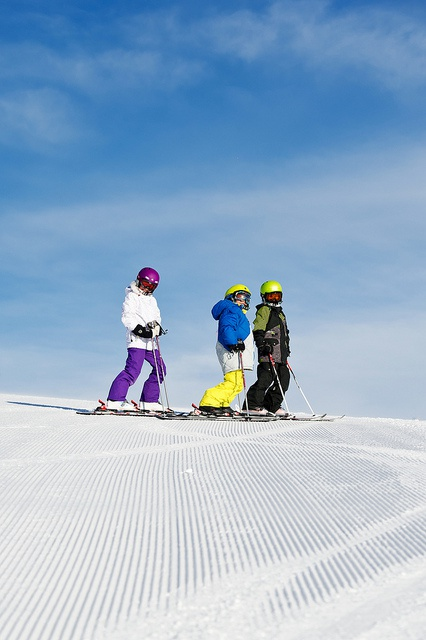Describe the objects in this image and their specific colors. I can see people in blue, white, purple, black, and darkgray tones, people in blue, black, gray, olive, and lightgray tones, people in blue, yellow, and lightgray tones, skis in blue, darkgray, gray, black, and lightgray tones, and skis in blue, black, lightgray, darkgray, and gray tones in this image. 